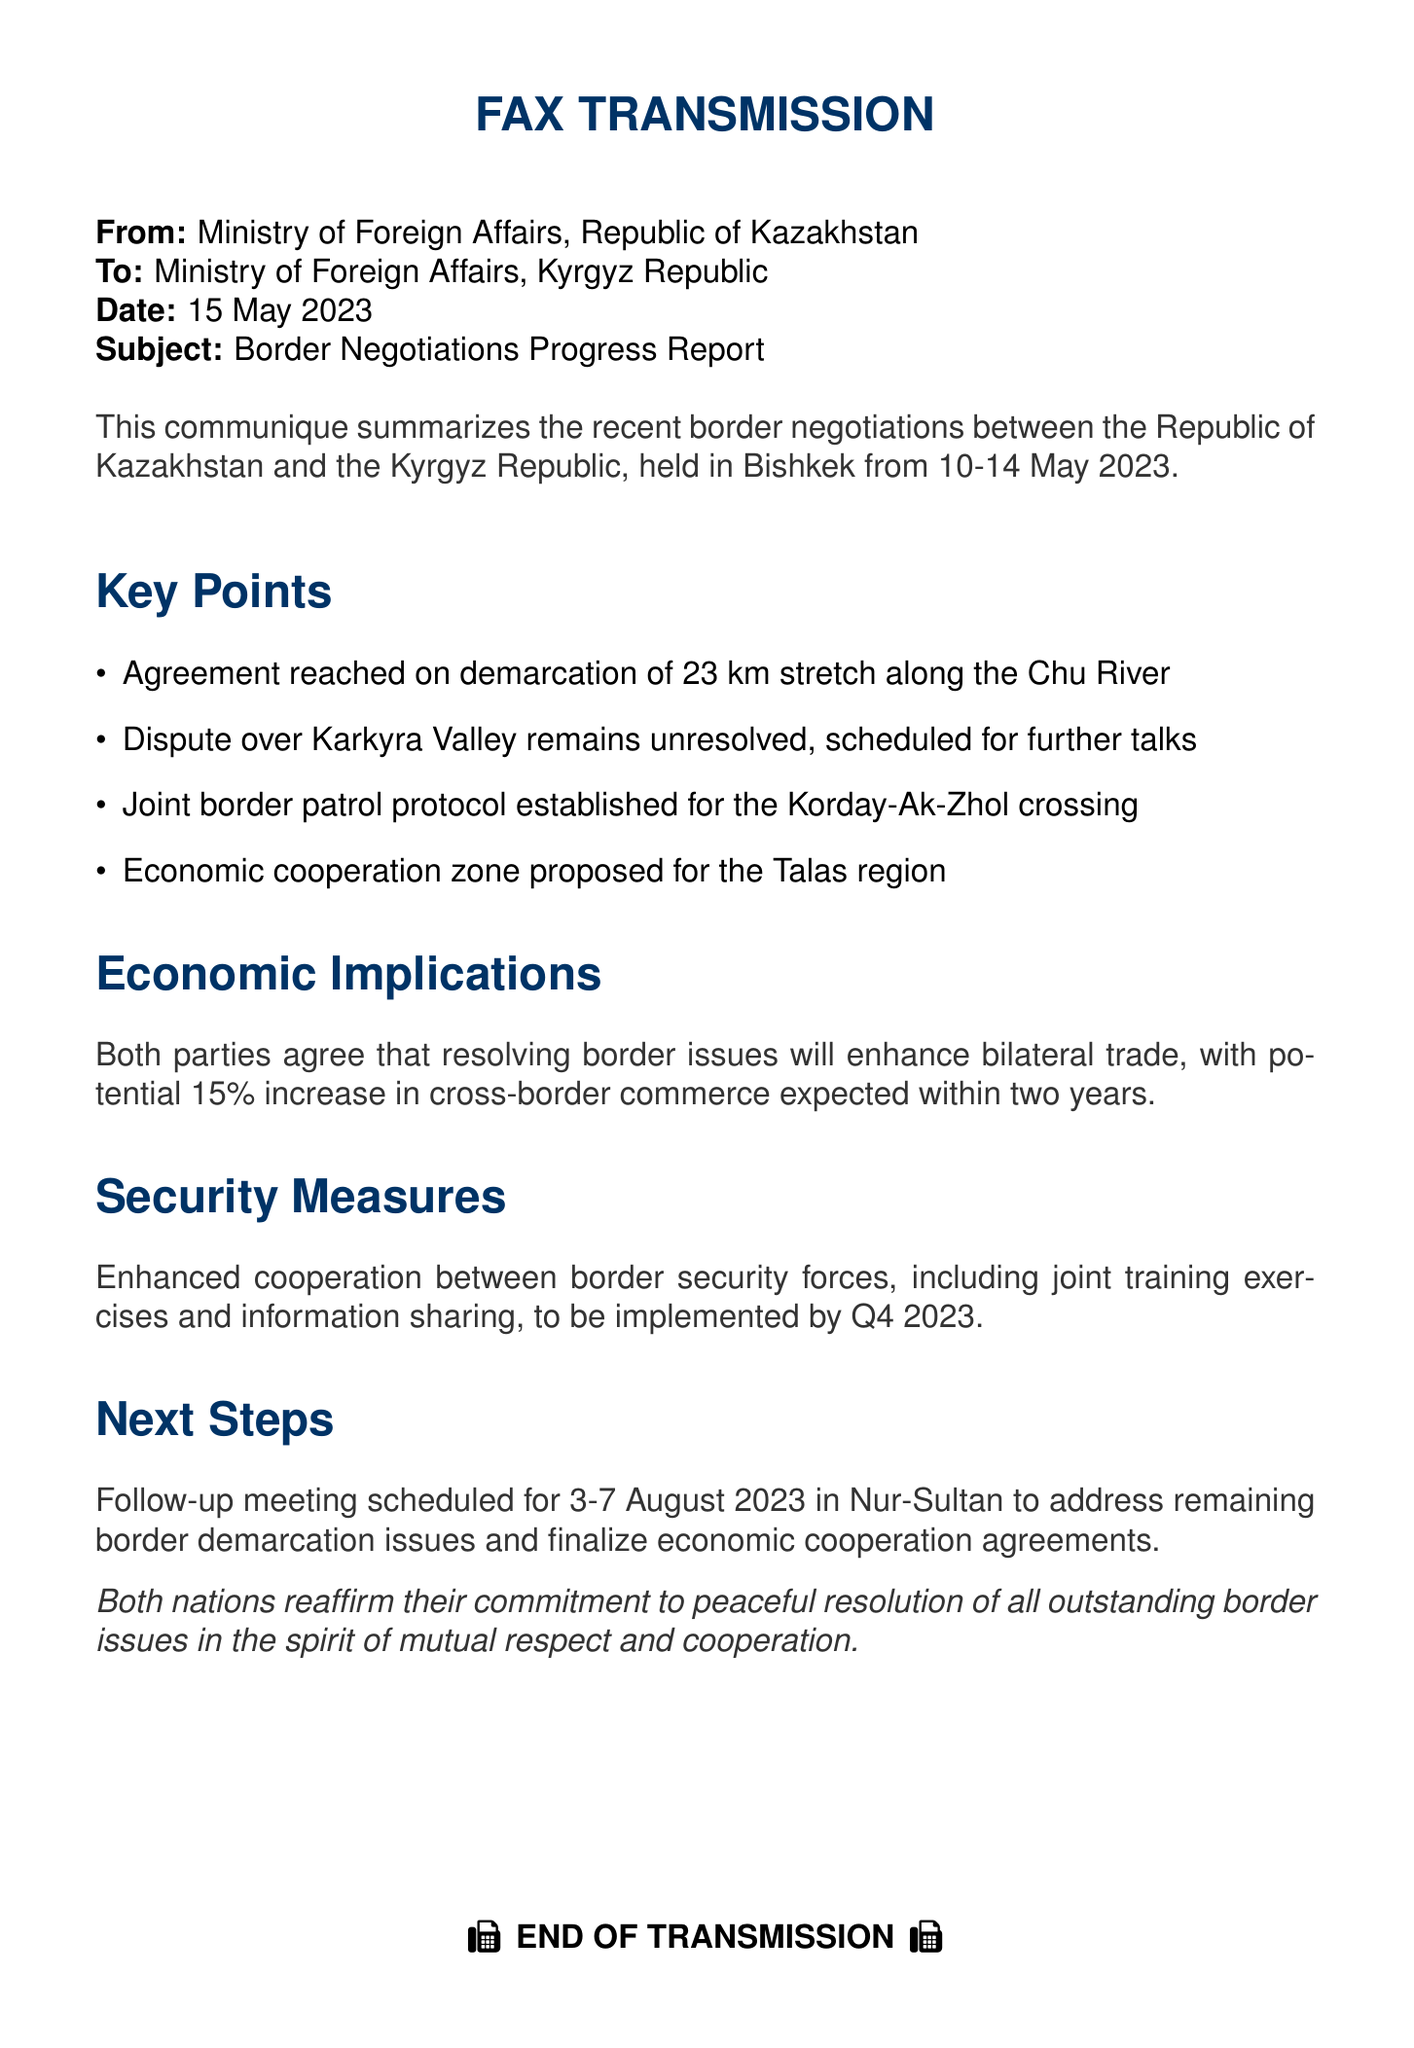What is the date of the fax? The fax is dated 15 May 2023, as stated in the document.
Answer: 15 May 2023 Who sent the fax? The fax was sent from the Ministry of Foreign Affairs, Republic of Kazakhstan.
Answer: Ministry of Foreign Affairs, Republic of Kazakhstan What is the total length of the border stretch agreed for demarcation? The total length agreed for demarcation is 23 km along the Chu River, as mentioned in the document.
Answer: 23 km When is the next follow-up meeting scheduled? The follow-up meeting is scheduled for 3-7 August 2023, as noted in the next steps section.
Answer: 3-7 August 2023 What unresolved issue is mentioned in the document? The document highlights a dispute over the Karkyra Valley as the unresolved issue.
Answer: Karkyra Valley What security measures will be implemented by Q4 2023? Enhanced cooperation between border security forces is the specific security measure to be implemented.
Answer: Enhanced cooperation What is the proposed economic outcome of resolving the border issues? The document states a potential 15% increase in cross-border commerce expected within two years.
Answer: 15% Which two countries are involved in the border negotiations? The negotiations involve the Republic of Kazakhstan and the Kyrgyz Republic, as stated at the beginning of the document.
Answer: Republic of Kazakhstan and Kyrgyz Republic 